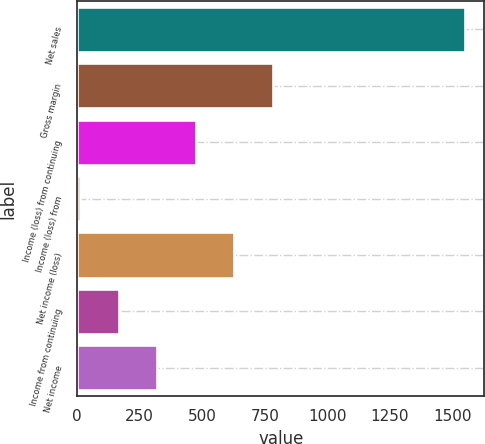Convert chart to OTSL. <chart><loc_0><loc_0><loc_500><loc_500><bar_chart><fcel>Net sales<fcel>Gross margin<fcel>Income (loss) from continuing<fcel>Income (loss) from<fcel>Net income (loss)<fcel>Income from continuing<fcel>Net income<nl><fcel>1549.9<fcel>780.55<fcel>472.81<fcel>11.2<fcel>626.68<fcel>165.07<fcel>318.94<nl></chart> 